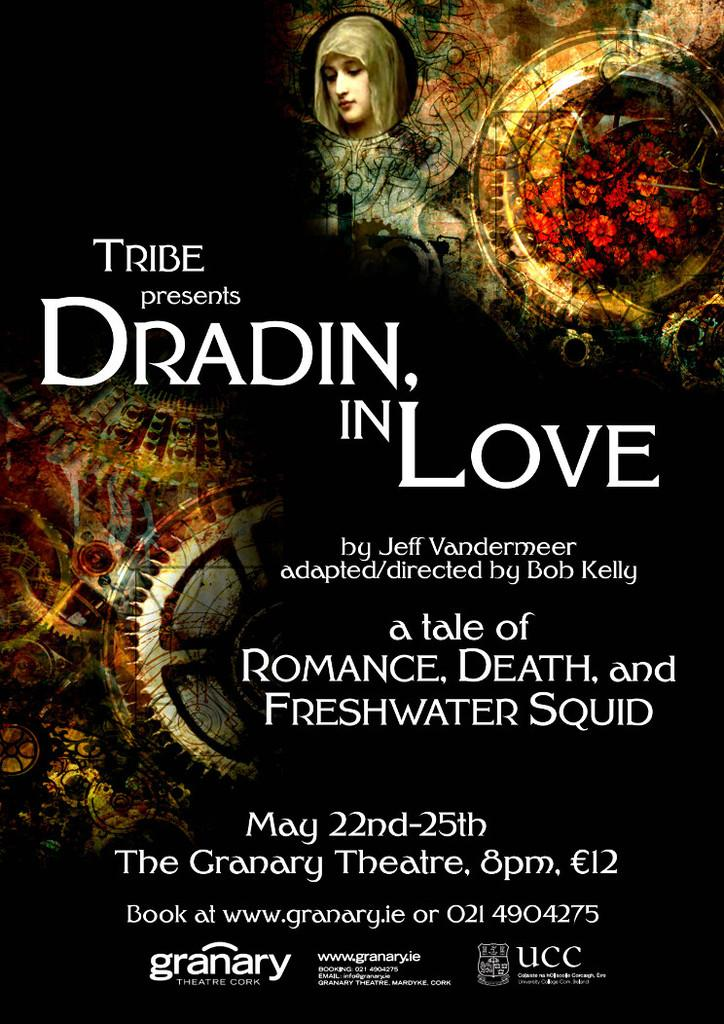<image>
Summarize the visual content of the image. A flyer promoting a theatrical performance called Dradin, in Love at the Granary theater. 